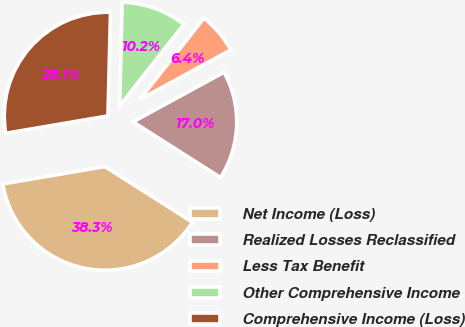<chart> <loc_0><loc_0><loc_500><loc_500><pie_chart><fcel>Net Income (Loss)<fcel>Realized Losses Reclassified<fcel>Less Tax Benefit<fcel>Other Comprehensive Income<fcel>Comprehensive Income (Loss)<nl><fcel>38.3%<fcel>16.96%<fcel>6.43%<fcel>10.23%<fcel>28.07%<nl></chart> 